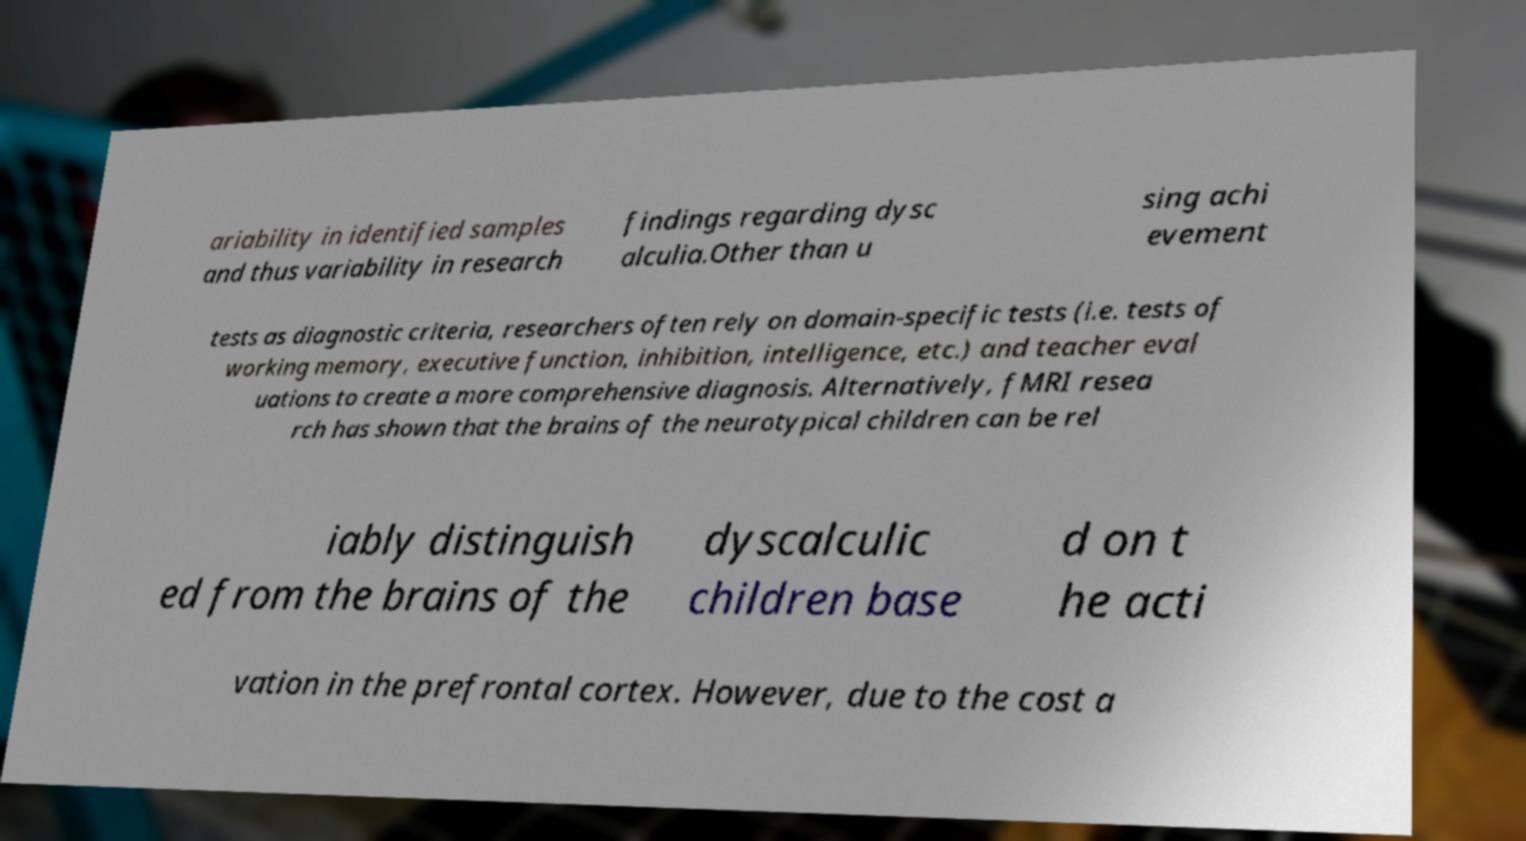Can you read and provide the text displayed in the image?This photo seems to have some interesting text. Can you extract and type it out for me? ariability in identified samples and thus variability in research findings regarding dysc alculia.Other than u sing achi evement tests as diagnostic criteria, researchers often rely on domain-specific tests (i.e. tests of working memory, executive function, inhibition, intelligence, etc.) and teacher eval uations to create a more comprehensive diagnosis. Alternatively, fMRI resea rch has shown that the brains of the neurotypical children can be rel iably distinguish ed from the brains of the dyscalculic children base d on t he acti vation in the prefrontal cortex. However, due to the cost a 